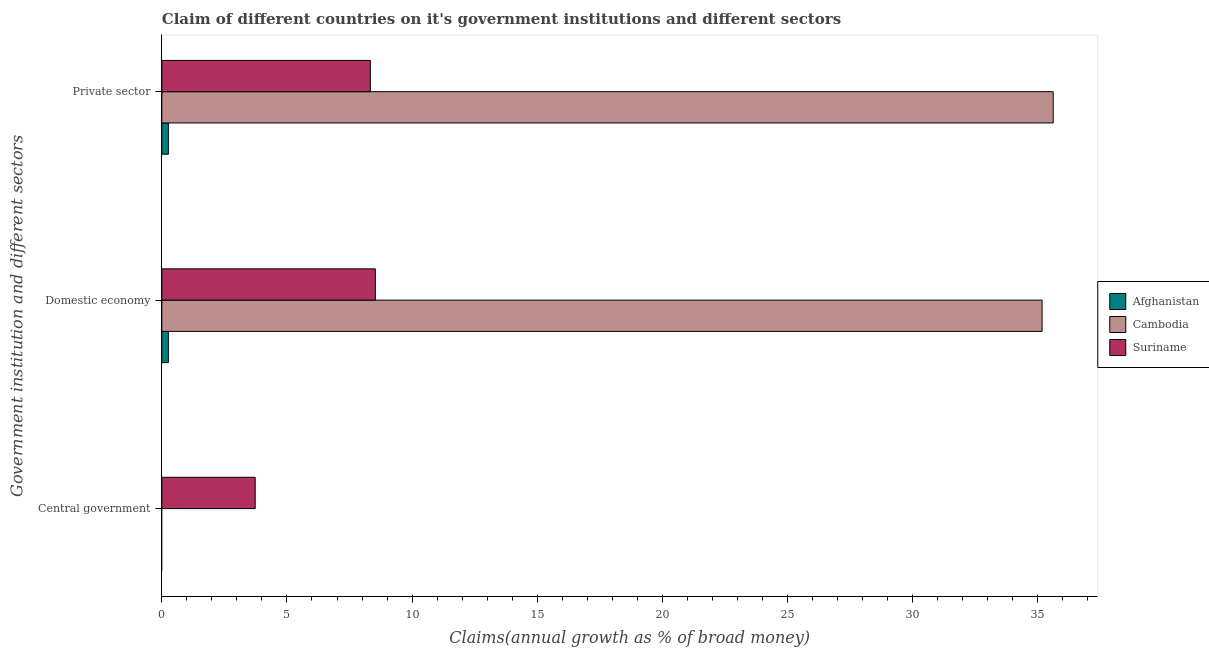How many bars are there on the 2nd tick from the top?
Provide a succinct answer. 3. What is the label of the 2nd group of bars from the top?
Your answer should be compact. Domestic economy. What is the percentage of claim on the private sector in Cambodia?
Provide a short and direct response. 35.62. Across all countries, what is the maximum percentage of claim on the domestic economy?
Offer a terse response. 35.18. Across all countries, what is the minimum percentage of claim on the central government?
Ensure brevity in your answer.  0. In which country was the percentage of claim on the central government maximum?
Offer a terse response. Suriname. What is the total percentage of claim on the central government in the graph?
Give a very brief answer. 3.73. What is the difference between the percentage of claim on the domestic economy in Suriname and that in Afghanistan?
Your answer should be compact. 8.27. What is the difference between the percentage of claim on the central government in Afghanistan and the percentage of claim on the domestic economy in Cambodia?
Offer a very short reply. -35.18. What is the average percentage of claim on the domestic economy per country?
Your answer should be compact. 14.66. What is the difference between the percentage of claim on the private sector and percentage of claim on the domestic economy in Afghanistan?
Ensure brevity in your answer.  0. In how many countries, is the percentage of claim on the private sector greater than 36 %?
Ensure brevity in your answer.  0. What is the ratio of the percentage of claim on the private sector in Suriname to that in Afghanistan?
Provide a succinct answer. 31.77. Is the percentage of claim on the domestic economy in Afghanistan less than that in Suriname?
Ensure brevity in your answer.  Yes. What is the difference between the highest and the second highest percentage of claim on the domestic economy?
Make the answer very short. 26.65. What is the difference between the highest and the lowest percentage of claim on the private sector?
Ensure brevity in your answer.  35.36. How many bars are there?
Provide a succinct answer. 7. Are all the bars in the graph horizontal?
Provide a succinct answer. Yes. How many countries are there in the graph?
Ensure brevity in your answer.  3. What is the difference between two consecutive major ticks on the X-axis?
Your answer should be very brief. 5. Are the values on the major ticks of X-axis written in scientific E-notation?
Ensure brevity in your answer.  No. Does the graph contain grids?
Your answer should be compact. No. Where does the legend appear in the graph?
Provide a succinct answer. Center right. How many legend labels are there?
Make the answer very short. 3. How are the legend labels stacked?
Offer a very short reply. Vertical. What is the title of the graph?
Your answer should be very brief. Claim of different countries on it's government institutions and different sectors. Does "South Asia" appear as one of the legend labels in the graph?
Your answer should be compact. No. What is the label or title of the X-axis?
Offer a terse response. Claims(annual growth as % of broad money). What is the label or title of the Y-axis?
Your answer should be very brief. Government institution and different sectors. What is the Claims(annual growth as % of broad money) in Cambodia in Central government?
Your response must be concise. 0. What is the Claims(annual growth as % of broad money) in Suriname in Central government?
Your answer should be compact. 3.73. What is the Claims(annual growth as % of broad money) of Afghanistan in Domestic economy?
Ensure brevity in your answer.  0.26. What is the Claims(annual growth as % of broad money) in Cambodia in Domestic economy?
Provide a succinct answer. 35.18. What is the Claims(annual growth as % of broad money) in Suriname in Domestic economy?
Offer a terse response. 8.53. What is the Claims(annual growth as % of broad money) of Afghanistan in Private sector?
Offer a very short reply. 0.26. What is the Claims(annual growth as % of broad money) of Cambodia in Private sector?
Provide a short and direct response. 35.62. What is the Claims(annual growth as % of broad money) of Suriname in Private sector?
Make the answer very short. 8.33. Across all Government institution and different sectors, what is the maximum Claims(annual growth as % of broad money) in Afghanistan?
Provide a short and direct response. 0.26. Across all Government institution and different sectors, what is the maximum Claims(annual growth as % of broad money) in Cambodia?
Offer a very short reply. 35.62. Across all Government institution and different sectors, what is the maximum Claims(annual growth as % of broad money) of Suriname?
Keep it short and to the point. 8.53. Across all Government institution and different sectors, what is the minimum Claims(annual growth as % of broad money) of Afghanistan?
Provide a short and direct response. 0. Across all Government institution and different sectors, what is the minimum Claims(annual growth as % of broad money) in Suriname?
Provide a short and direct response. 3.73. What is the total Claims(annual growth as % of broad money) of Afghanistan in the graph?
Offer a terse response. 0.52. What is the total Claims(annual growth as % of broad money) in Cambodia in the graph?
Your answer should be compact. 70.8. What is the total Claims(annual growth as % of broad money) in Suriname in the graph?
Your answer should be very brief. 20.6. What is the difference between the Claims(annual growth as % of broad money) of Suriname in Central government and that in Domestic economy?
Provide a short and direct response. -4.8. What is the difference between the Claims(annual growth as % of broad money) in Suriname in Central government and that in Private sector?
Offer a terse response. -4.6. What is the difference between the Claims(annual growth as % of broad money) of Afghanistan in Domestic economy and that in Private sector?
Your answer should be compact. 0. What is the difference between the Claims(annual growth as % of broad money) in Cambodia in Domestic economy and that in Private sector?
Offer a terse response. -0.44. What is the difference between the Claims(annual growth as % of broad money) in Suriname in Domestic economy and that in Private sector?
Your answer should be very brief. 0.2. What is the difference between the Claims(annual growth as % of broad money) of Afghanistan in Domestic economy and the Claims(annual growth as % of broad money) of Cambodia in Private sector?
Give a very brief answer. -35.36. What is the difference between the Claims(annual growth as % of broad money) of Afghanistan in Domestic economy and the Claims(annual growth as % of broad money) of Suriname in Private sector?
Your response must be concise. -8.07. What is the difference between the Claims(annual growth as % of broad money) of Cambodia in Domestic economy and the Claims(annual growth as % of broad money) of Suriname in Private sector?
Your answer should be compact. 26.84. What is the average Claims(annual growth as % of broad money) in Afghanistan per Government institution and different sectors?
Provide a succinct answer. 0.17. What is the average Claims(annual growth as % of broad money) in Cambodia per Government institution and different sectors?
Your answer should be compact. 23.6. What is the average Claims(annual growth as % of broad money) of Suriname per Government institution and different sectors?
Your answer should be very brief. 6.87. What is the difference between the Claims(annual growth as % of broad money) of Afghanistan and Claims(annual growth as % of broad money) of Cambodia in Domestic economy?
Offer a very short reply. -34.92. What is the difference between the Claims(annual growth as % of broad money) of Afghanistan and Claims(annual growth as % of broad money) of Suriname in Domestic economy?
Your answer should be very brief. -8.27. What is the difference between the Claims(annual growth as % of broad money) in Cambodia and Claims(annual growth as % of broad money) in Suriname in Domestic economy?
Keep it short and to the point. 26.65. What is the difference between the Claims(annual growth as % of broad money) in Afghanistan and Claims(annual growth as % of broad money) in Cambodia in Private sector?
Your answer should be very brief. -35.36. What is the difference between the Claims(annual growth as % of broad money) in Afghanistan and Claims(annual growth as % of broad money) in Suriname in Private sector?
Keep it short and to the point. -8.07. What is the difference between the Claims(annual growth as % of broad money) of Cambodia and Claims(annual growth as % of broad money) of Suriname in Private sector?
Provide a short and direct response. 27.29. What is the ratio of the Claims(annual growth as % of broad money) of Suriname in Central government to that in Domestic economy?
Provide a succinct answer. 0.44. What is the ratio of the Claims(annual growth as % of broad money) in Suriname in Central government to that in Private sector?
Provide a short and direct response. 0.45. What is the ratio of the Claims(annual growth as % of broad money) in Cambodia in Domestic economy to that in Private sector?
Give a very brief answer. 0.99. What is the ratio of the Claims(annual growth as % of broad money) in Suriname in Domestic economy to that in Private sector?
Make the answer very short. 1.02. What is the difference between the highest and the second highest Claims(annual growth as % of broad money) of Suriname?
Provide a succinct answer. 0.2. What is the difference between the highest and the lowest Claims(annual growth as % of broad money) of Afghanistan?
Give a very brief answer. 0.26. What is the difference between the highest and the lowest Claims(annual growth as % of broad money) in Cambodia?
Provide a short and direct response. 35.62. What is the difference between the highest and the lowest Claims(annual growth as % of broad money) of Suriname?
Offer a very short reply. 4.8. 